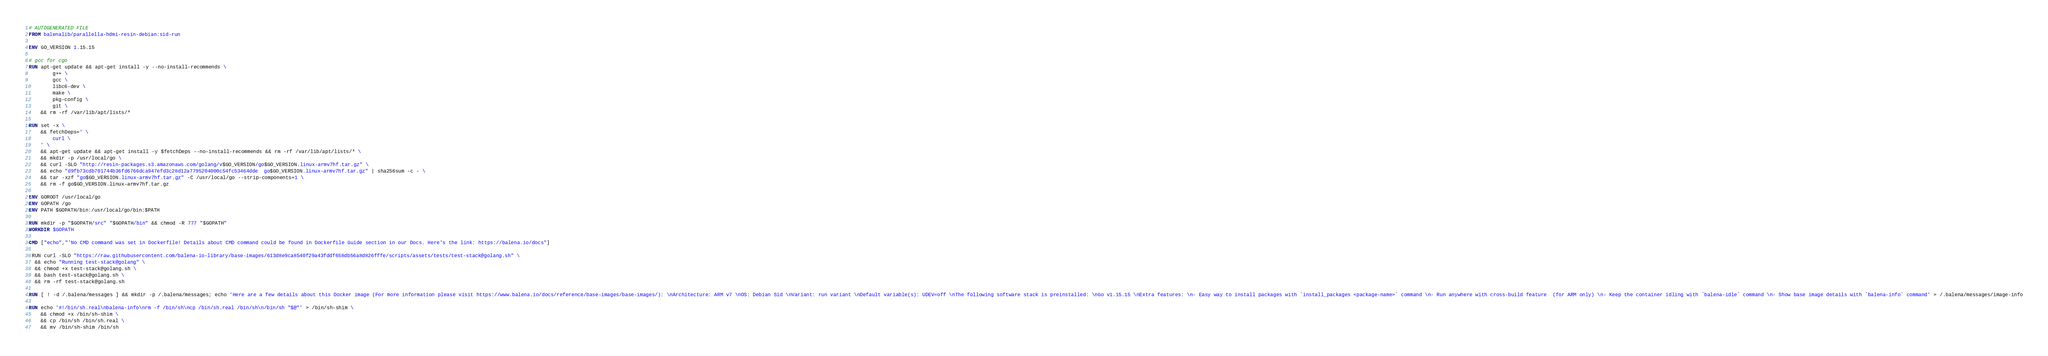Convert code to text. <code><loc_0><loc_0><loc_500><loc_500><_Dockerfile_># AUTOGENERATED FILE
FROM balenalib/parallella-hdmi-resin-debian:sid-run

ENV GO_VERSION 1.15.15

# gcc for cgo
RUN apt-get update && apt-get install -y --no-install-recommends \
		g++ \
		gcc \
		libc6-dev \
		make \
		pkg-config \
		git \
	&& rm -rf /var/lib/apt/lists/*

RUN set -x \
	&& fetchDeps=' \
		curl \
	' \
	&& apt-get update && apt-get install -y $fetchDeps --no-install-recommends && rm -rf /var/lib/apt/lists/* \
	&& mkdir -p /usr/local/go \
	&& curl -SLO "http://resin-packages.s3.amazonaws.com/golang/v$GO_VERSION/go$GO_VERSION.linux-armv7hf.tar.gz" \
	&& echo "d9fb73cdb701744b36fd6766dca947efd3c28d12a7795204000c54fc53464dde  go$GO_VERSION.linux-armv7hf.tar.gz" | sha256sum -c - \
	&& tar -xzf "go$GO_VERSION.linux-armv7hf.tar.gz" -C /usr/local/go --strip-components=1 \
	&& rm -f go$GO_VERSION.linux-armv7hf.tar.gz

ENV GOROOT /usr/local/go
ENV GOPATH /go
ENV PATH $GOPATH/bin:/usr/local/go/bin:$PATH

RUN mkdir -p "$GOPATH/src" "$GOPATH/bin" && chmod -R 777 "$GOPATH"
WORKDIR $GOPATH

CMD ["echo","'No CMD command was set in Dockerfile! Details about CMD command could be found in Dockerfile Guide section in our Docs. Here's the link: https://balena.io/docs"]

 RUN curl -SLO "https://raw.githubusercontent.com/balena-io-library/base-images/613d8e9ca8540f29a43fddf658db56a8d826fffe/scripts/assets/tests/test-stack@golang.sh" \
  && echo "Running test-stack@golang" \
  && chmod +x test-stack@golang.sh \
  && bash test-stack@golang.sh \
  && rm -rf test-stack@golang.sh 

RUN [ ! -d /.balena/messages ] && mkdir -p /.balena/messages; echo 'Here are a few details about this Docker image (For more information please visit https://www.balena.io/docs/reference/base-images/base-images/): \nArchitecture: ARM v7 \nOS: Debian Sid \nVariant: run variant \nDefault variable(s): UDEV=off \nThe following software stack is preinstalled: \nGo v1.15.15 \nExtra features: \n- Easy way to install packages with `install_packages <package-name>` command \n- Run anywhere with cross-build feature  (for ARM only) \n- Keep the container idling with `balena-idle` command \n- Show base image details with `balena-info` command' > /.balena/messages/image-info

RUN echo '#!/bin/sh.real\nbalena-info\nrm -f /bin/sh\ncp /bin/sh.real /bin/sh\n/bin/sh "$@"' > /bin/sh-shim \
	&& chmod +x /bin/sh-shim \
	&& cp /bin/sh /bin/sh.real \
	&& mv /bin/sh-shim /bin/sh</code> 